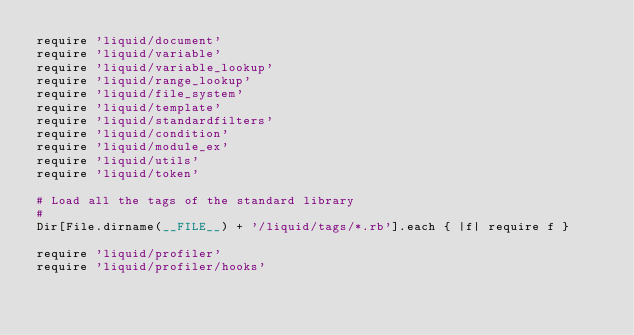<code> <loc_0><loc_0><loc_500><loc_500><_Ruby_>require 'liquid/document'
require 'liquid/variable'
require 'liquid/variable_lookup'
require 'liquid/range_lookup'
require 'liquid/file_system'
require 'liquid/template'
require 'liquid/standardfilters'
require 'liquid/condition'
require 'liquid/module_ex'
require 'liquid/utils'
require 'liquid/token'

# Load all the tags of the standard library
#
Dir[File.dirname(__FILE__) + '/liquid/tags/*.rb'].each { |f| require f }

require 'liquid/profiler'
require 'liquid/profiler/hooks'
</code> 